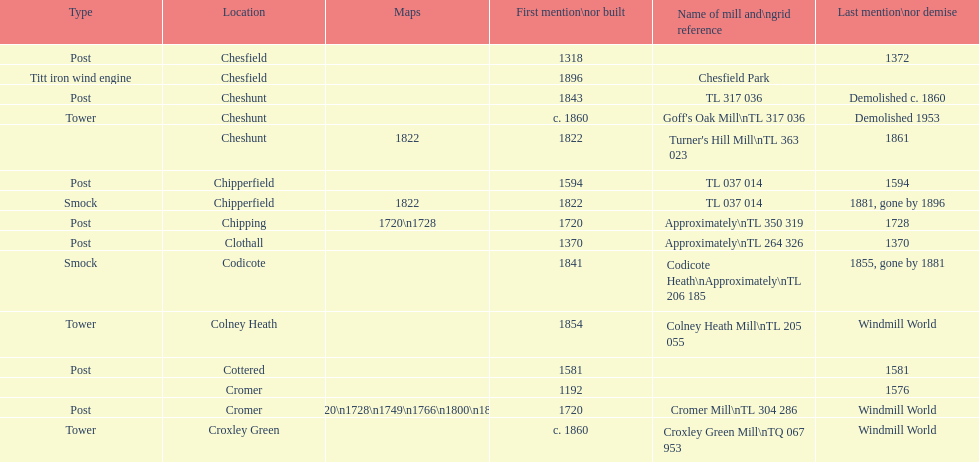What location has the most maps? Cromer. 